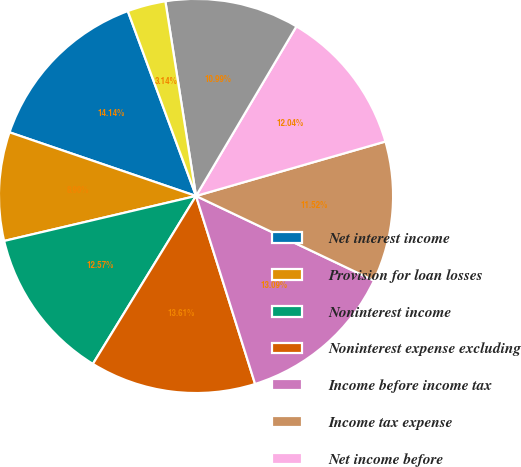Convert chart to OTSL. <chart><loc_0><loc_0><loc_500><loc_500><pie_chart><fcel>Net interest income<fcel>Provision for loan losses<fcel>Noninterest income<fcel>Noninterest expense excluding<fcel>Income before income tax<fcel>Income tax expense<fcel>Net income before<fcel>Net (income) loss attributable<fcel>Earnings per common<nl><fcel>14.14%<fcel>8.9%<fcel>12.57%<fcel>13.61%<fcel>13.09%<fcel>11.52%<fcel>12.04%<fcel>10.99%<fcel>3.14%<nl></chart> 